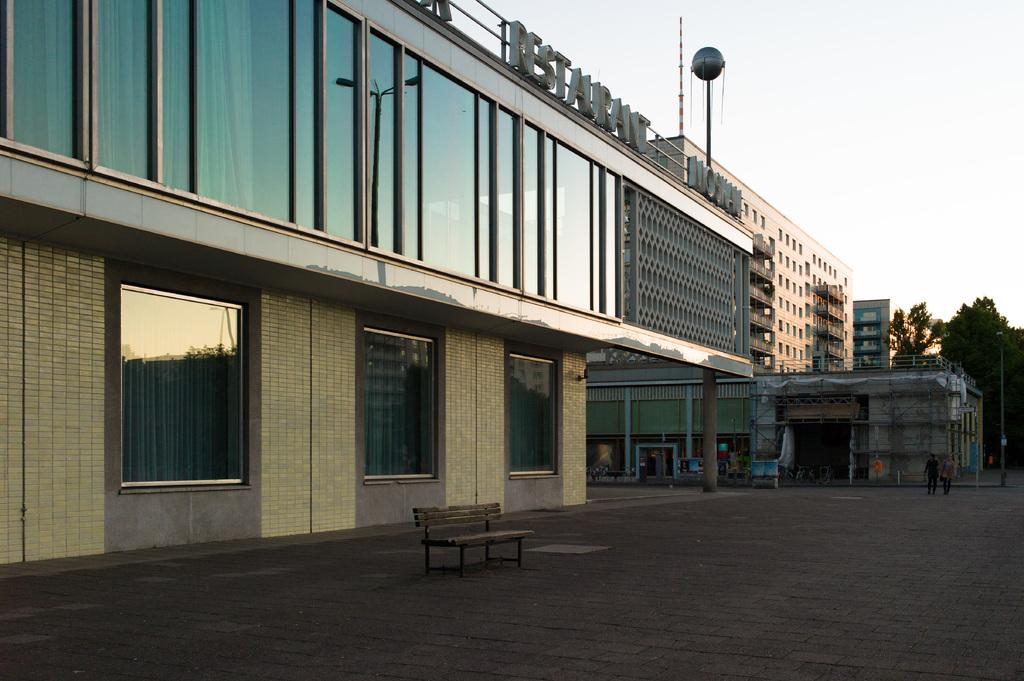What type of structures can be seen in the picture? There are buildings in the picture. What objects are present near the buildings? There are trees beside the buildings. What can be seen in the background of the picture? The sky is visible in the background of the picture. What objects might be used for drinking or holding liquids in the picture? There are glasses in the picture. How many servants are visible in the picture? There are no servants present in the picture. What is the size of the window in the picture? There is no window visible in the picture. 